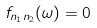Convert formula to latex. <formula><loc_0><loc_0><loc_500><loc_500>f _ { n _ { 1 } n _ { 2 } } ( \omega ) = 0</formula> 